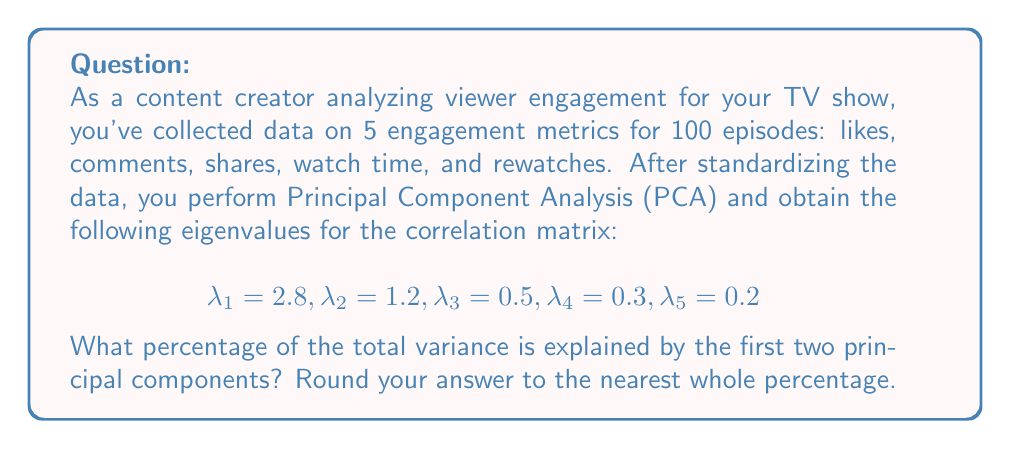Provide a solution to this math problem. To solve this problem, we'll follow these steps:

1) First, recall that in PCA, each eigenvalue represents the amount of variance explained by its corresponding principal component.

2) The total variance in a standardized dataset is equal to the number of variables. In this case, we have 5 variables, so the total variance is 5.

3) To calculate the percentage of variance explained by the first two principal components, we need to:
   a) Sum the eigenvalues of the first two components
   b) Divide this sum by the total variance
   c) Multiply by 100 to get a percentage

4) Let's perform these calculations:

   a) Sum of first two eigenvalues:
      $\lambda_1 + \lambda_2 = 2.8 + 1.2 = 4$

   b) Divide by total variance:
      $\frac{4}{5} = 0.8$

   c) Convert to percentage:
      $0.8 \times 100 = 80\%$

5) Rounding to the nearest whole percentage, we get 80%.

This means that the first two principal components account for 80% of the total variance in your viewer engagement data, indicating that these two components capture a large portion of the information in your original 5 metrics.
Answer: 80% 